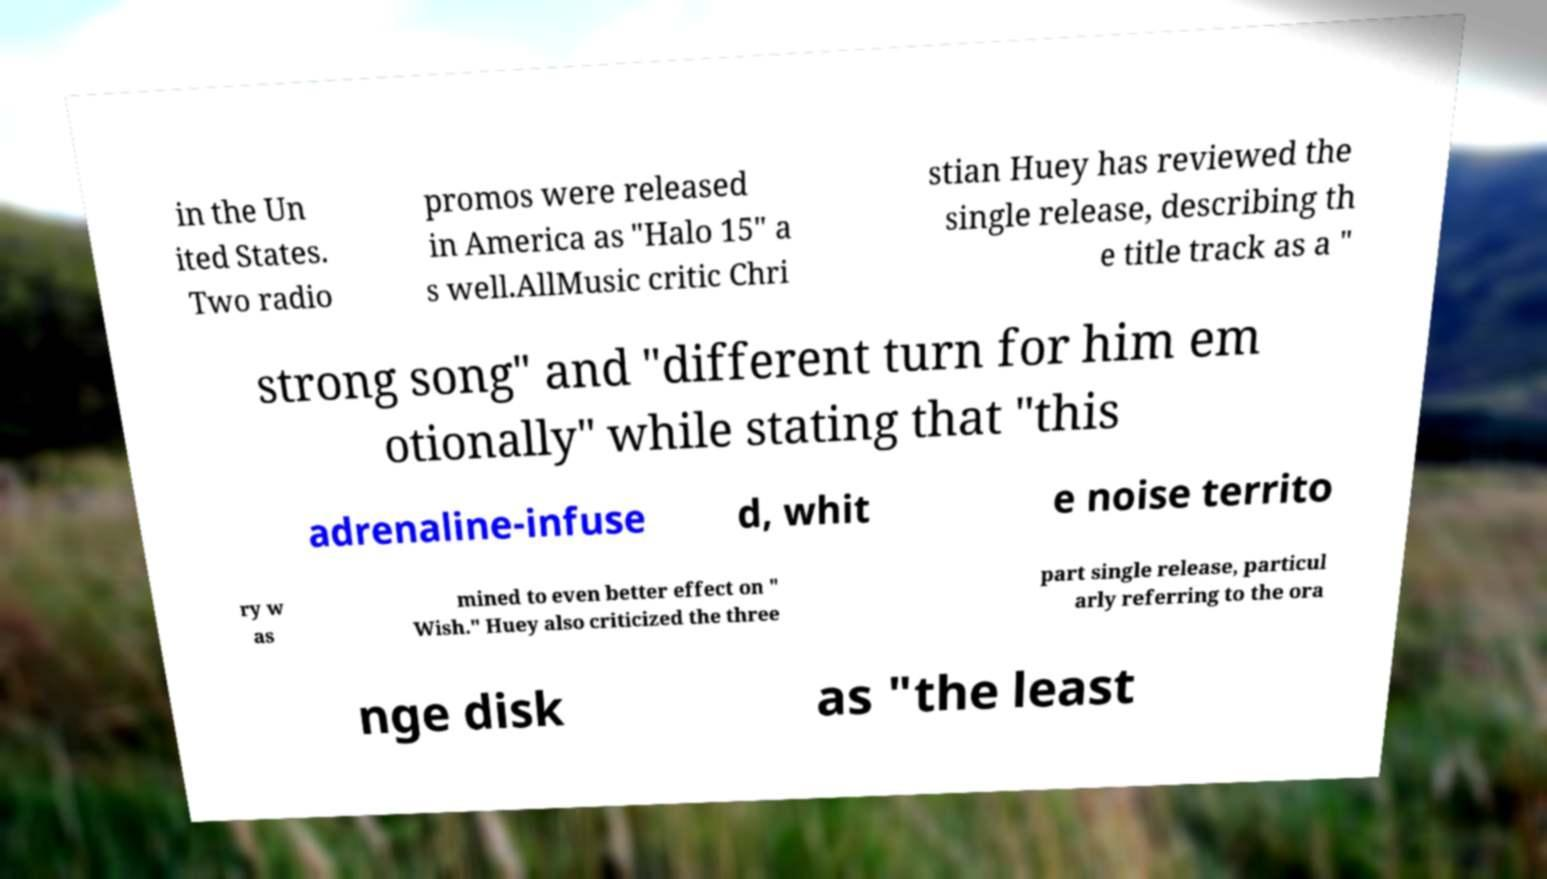Can you read and provide the text displayed in the image?This photo seems to have some interesting text. Can you extract and type it out for me? in the Un ited States. Two radio promos were released in America as "Halo 15" a s well.AllMusic critic Chri stian Huey has reviewed the single release, describing th e title track as a " strong song" and "different turn for him em otionally" while stating that "this adrenaline-infuse d, whit e noise territo ry w as mined to even better effect on " Wish." Huey also criticized the three part single release, particul arly referring to the ora nge disk as "the least 